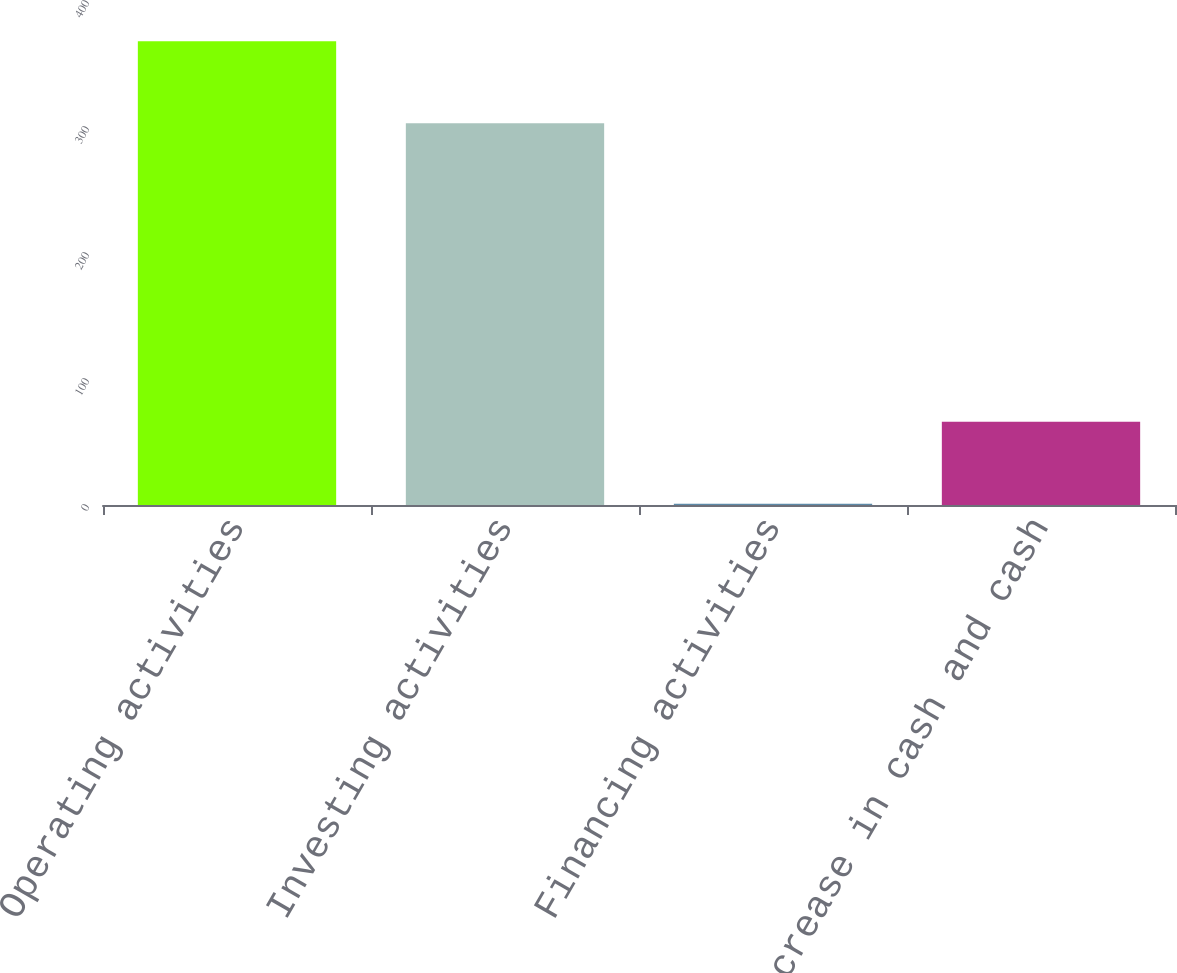Convert chart. <chart><loc_0><loc_0><loc_500><loc_500><bar_chart><fcel>Operating activities<fcel>Investing activities<fcel>Financing activities<fcel>Net increase in cash and cash<nl><fcel>368<fcel>303<fcel>1<fcel>66<nl></chart> 